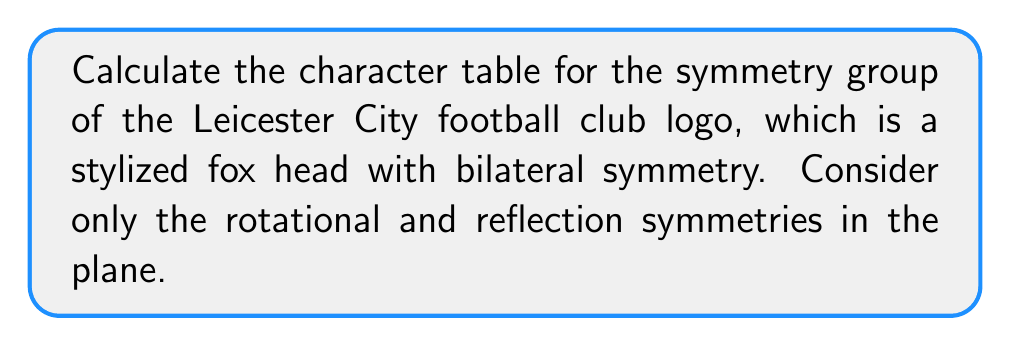Can you answer this question? Let's approach this step-by-step:

1) First, we need to identify the symmetry group of the Leicester City logo. The logo has bilateral symmetry, which means it has:
   - Identity operation (E)
   - 180° rotation (C₂)
   - Reflection about the vertical axis (σᵥ)
   - Reflection about the horizontal axis (σₕ)

   This group is isomorphic to the Klein four-group, also known as $C_2 \times C_2$.

2) The group has four elements, so it will have four irreducible representations and four conjugacy classes.

3) The conjugacy classes are:
   {E}, {C₂}, {σᵥ}, {σₕ}

4) For a group of order 4, we know there will be four 1-dimensional irreducible representations.

5) Let's label these representations as $\chi_1, \chi_2, \chi_3, \chi_4$.

6) $\chi_1$ is always the trivial representation, which maps every element to 1.

7) For the other representations, we need to ensure orthogonality. We can deduce:

   $\chi_2$: 1 for E and C₂, -1 for σᵥ and σₕ
   $\chi_3$: 1 for E and σᵥ, -1 for C₂ and σₕ
   $\chi_4$: 1 for E and σₕ, -1 for C₂ and σᵥ

8) We can now construct the character table:

   $$
   \begin{array}{c|cccc}
      & E & C_2 & \sigma_v & \sigma_h \\
   \hline
   \chi_1 & 1 & 1 & 1 & 1 \\
   \chi_2 & 1 & 1 & -1 & -1 \\
   \chi_3 & 1 & -1 & 1 & -1 \\
   \chi_4 & 1 & -1 & -1 & 1
   \end{array}
   $$

This character table fully describes the symmetry group of the Leicester City logo.
Answer: $$
\begin{array}{c|cccc}
   & E & C_2 & \sigma_v & \sigma_h \\
\hline
\chi_1 & 1 & 1 & 1 & 1 \\
\chi_2 & 1 & 1 & -1 & -1 \\
\chi_3 & 1 & -1 & 1 & -1 \\
\chi_4 & 1 & -1 & -1 & 1
\end{array}
$$ 